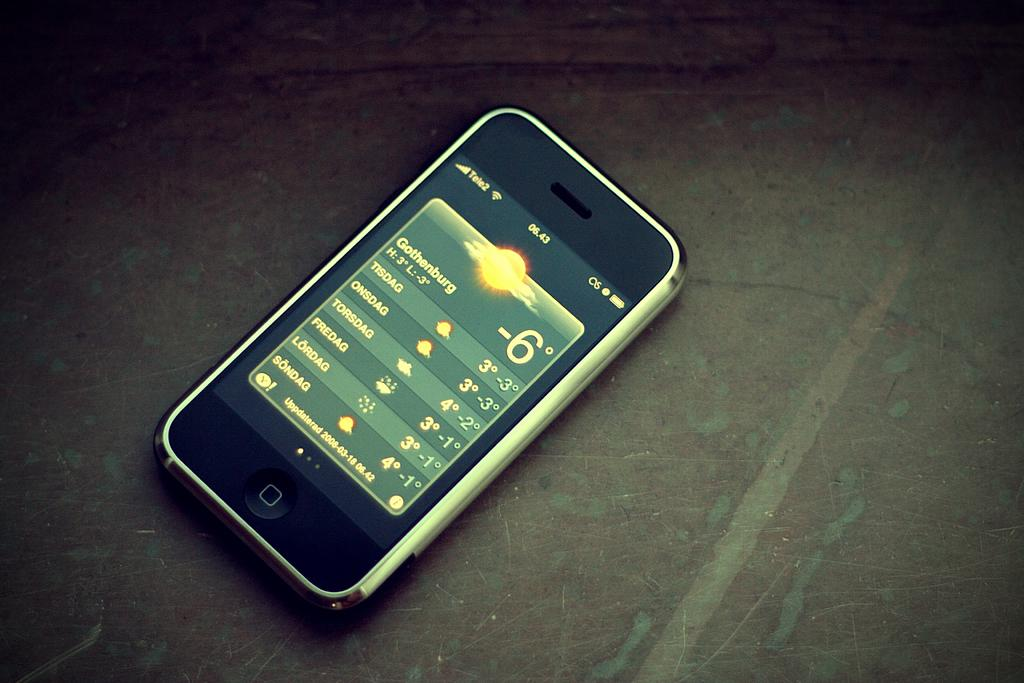<image>
Create a compact narrative representing the image presented. An iPhone opened up to the weather app where it is currently -6 in Gothenburg. 